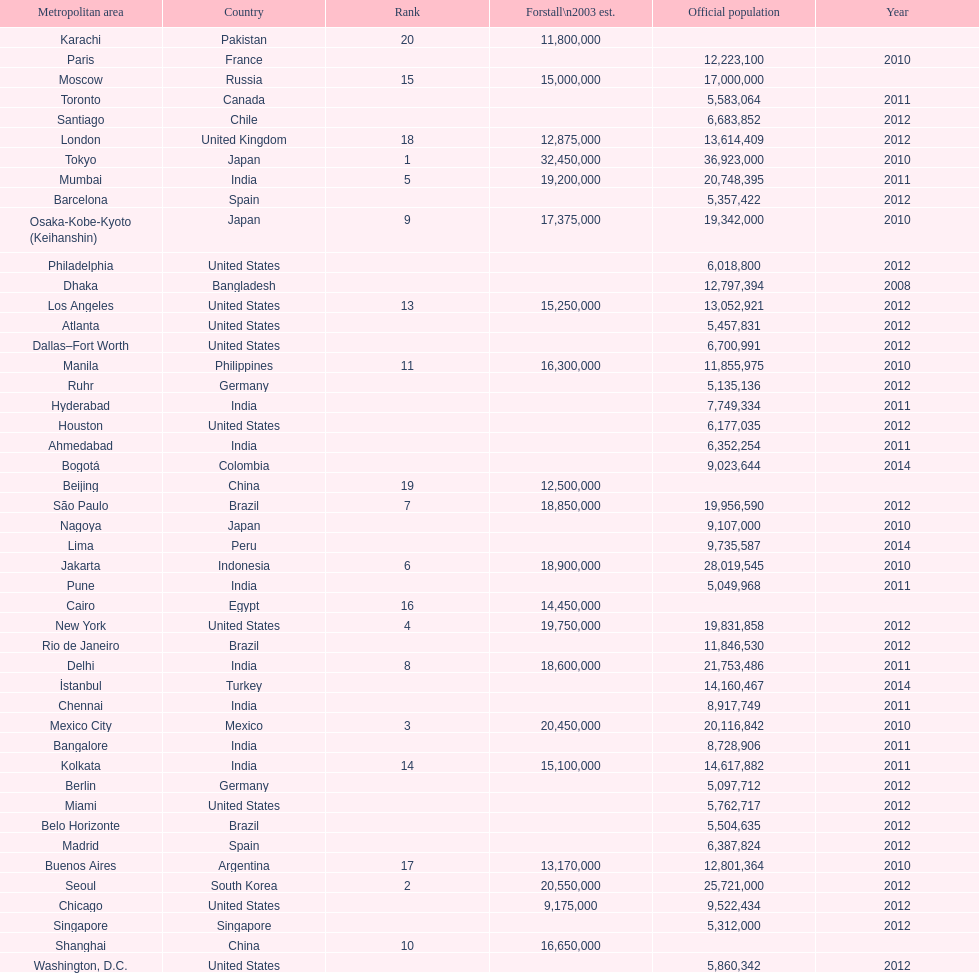How many cities are in the united states? 9. 